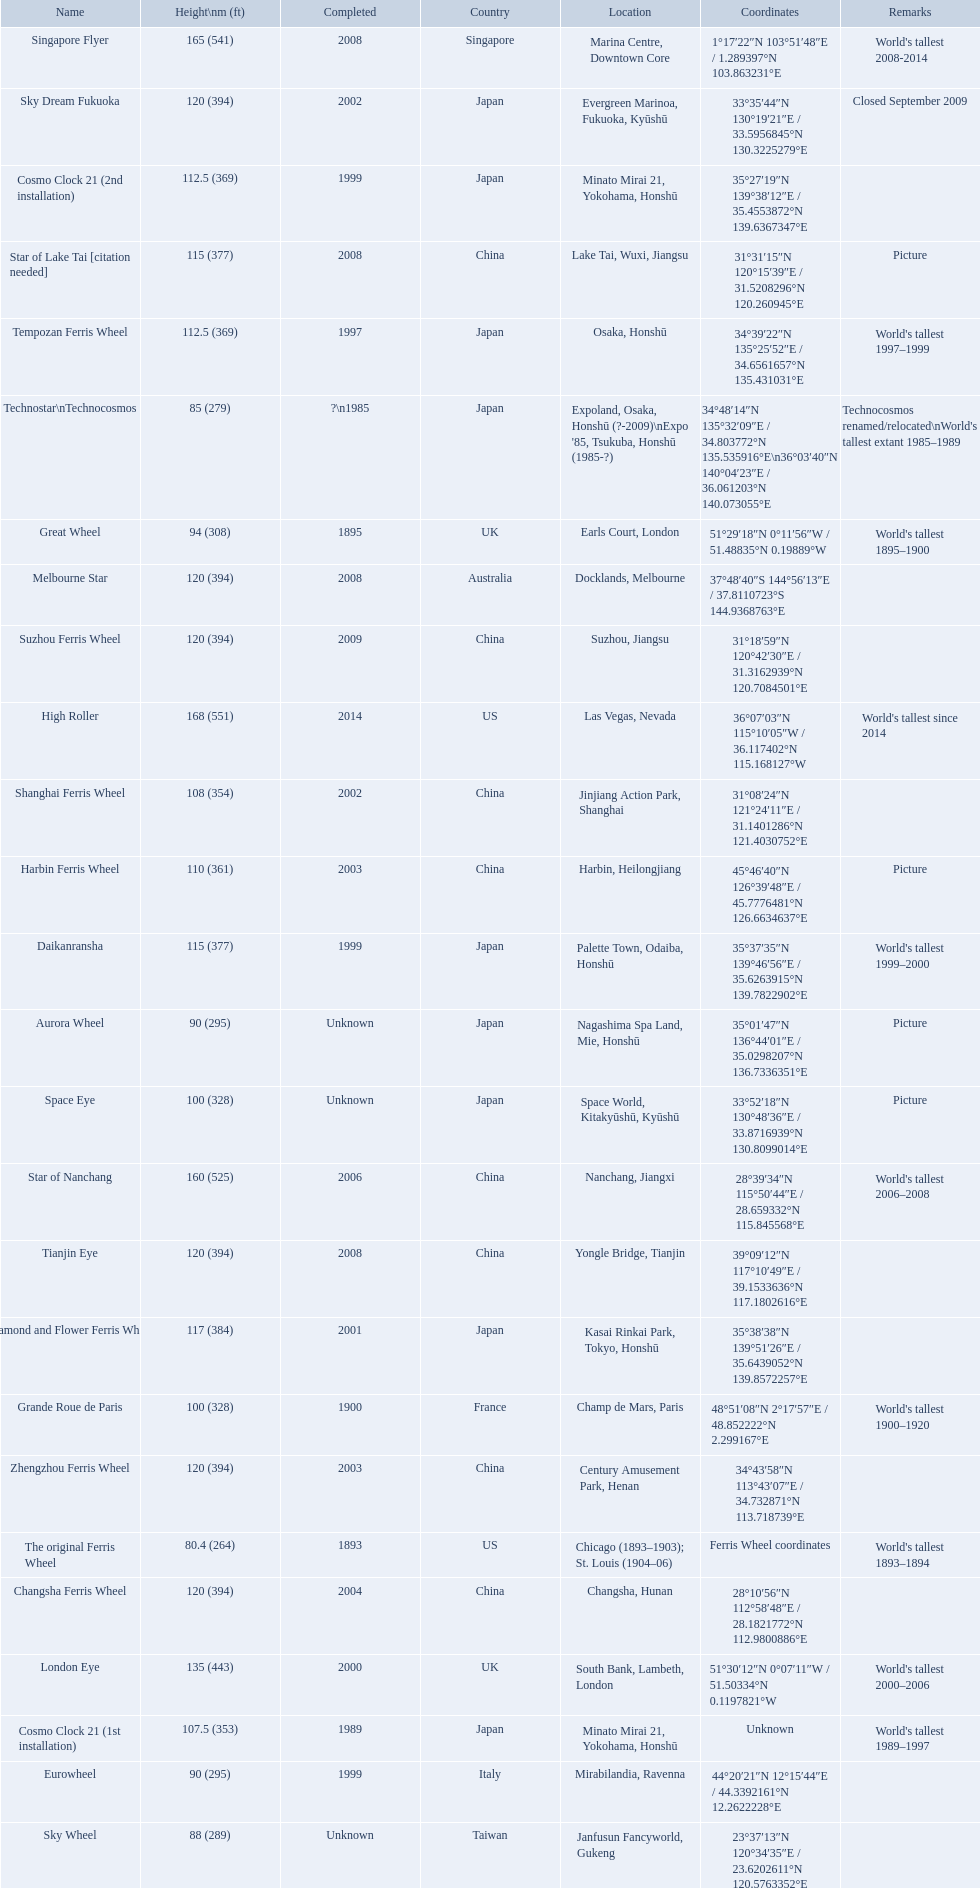What ferris wheels were completed in 2008 Singapore Flyer, Melbourne Star, Tianjin Eye, Star of Lake Tai [citation needed]. Would you be able to parse every entry in this table? {'header': ['Name', 'Height\\nm (ft)', 'Completed', 'Country', 'Location', 'Coordinates', 'Remarks'], 'rows': [['Singapore Flyer', '165 (541)', '2008', 'Singapore', 'Marina Centre, Downtown Core', '1°17′22″N 103°51′48″E\ufeff / \ufeff1.289397°N 103.863231°E', "World's tallest 2008-2014"], ['Sky Dream Fukuoka', '120 (394)', '2002', 'Japan', 'Evergreen Marinoa, Fukuoka, Kyūshū', '33°35′44″N 130°19′21″E\ufeff / \ufeff33.5956845°N 130.3225279°E', 'Closed September 2009'], ['Cosmo Clock 21 (2nd installation)', '112.5 (369)', '1999', 'Japan', 'Minato Mirai 21, Yokohama, Honshū', '35°27′19″N 139°38′12″E\ufeff / \ufeff35.4553872°N 139.6367347°E', ''], ['Star of Lake Tai\xa0[citation needed]', '115 (377)', '2008', 'China', 'Lake Tai, Wuxi, Jiangsu', '31°31′15″N 120°15′39″E\ufeff / \ufeff31.5208296°N 120.260945°E', 'Picture'], ['Tempozan Ferris Wheel', '112.5 (369)', '1997', 'Japan', 'Osaka, Honshū', '34°39′22″N 135°25′52″E\ufeff / \ufeff34.6561657°N 135.431031°E', "World's tallest 1997–1999"], ['Technostar\\nTechnocosmos', '85 (279)', '?\\n1985', 'Japan', "Expoland, Osaka, Honshū (?-2009)\\nExpo '85, Tsukuba, Honshū (1985-?)", '34°48′14″N 135°32′09″E\ufeff / \ufeff34.803772°N 135.535916°E\\n36°03′40″N 140°04′23″E\ufeff / \ufeff36.061203°N 140.073055°E', "Technocosmos renamed/relocated\\nWorld's tallest extant 1985–1989"], ['Great Wheel', '94 (308)', '1895', 'UK', 'Earls Court, London', '51°29′18″N 0°11′56″W\ufeff / \ufeff51.48835°N 0.19889°W', "World's tallest 1895–1900"], ['Melbourne Star', '120 (394)', '2008', 'Australia', 'Docklands, Melbourne', '37°48′40″S 144°56′13″E\ufeff / \ufeff37.8110723°S 144.9368763°E', ''], ['Suzhou Ferris Wheel', '120 (394)', '2009', 'China', 'Suzhou, Jiangsu', '31°18′59″N 120°42′30″E\ufeff / \ufeff31.3162939°N 120.7084501°E', ''], ['High Roller', '168 (551)', '2014', 'US', 'Las Vegas, Nevada', '36°07′03″N 115°10′05″W\ufeff / \ufeff36.117402°N 115.168127°W', "World's tallest since 2014"], ['Shanghai Ferris Wheel', '108 (354)', '2002', 'China', 'Jinjiang Action Park, Shanghai', '31°08′24″N 121°24′11″E\ufeff / \ufeff31.1401286°N 121.4030752°E', ''], ['Harbin Ferris Wheel', '110 (361)', '2003', 'China', 'Harbin, Heilongjiang', '45°46′40″N 126°39′48″E\ufeff / \ufeff45.7776481°N 126.6634637°E', 'Picture'], ['Daikanransha', '115 (377)', '1999', 'Japan', 'Palette Town, Odaiba, Honshū', '35°37′35″N 139°46′56″E\ufeff / \ufeff35.6263915°N 139.7822902°E', "World's tallest 1999–2000"], ['Aurora Wheel', '90 (295)', 'Unknown', 'Japan', 'Nagashima Spa Land, Mie, Honshū', '35°01′47″N 136°44′01″E\ufeff / \ufeff35.0298207°N 136.7336351°E', 'Picture'], ['Space Eye', '100 (328)', 'Unknown', 'Japan', 'Space World, Kitakyūshū, Kyūshū', '33°52′18″N 130°48′36″E\ufeff / \ufeff33.8716939°N 130.8099014°E', 'Picture'], ['Star of Nanchang', '160 (525)', '2006', 'China', 'Nanchang, Jiangxi', '28°39′34″N 115°50′44″E\ufeff / \ufeff28.659332°N 115.845568°E', "World's tallest 2006–2008"], ['Tianjin Eye', '120 (394)', '2008', 'China', 'Yongle Bridge, Tianjin', '39°09′12″N 117°10′49″E\ufeff / \ufeff39.1533636°N 117.1802616°E', ''], ['Diamond\xa0and\xa0Flower\xa0Ferris\xa0Wheel', '117 (384)', '2001', 'Japan', 'Kasai Rinkai Park, Tokyo, Honshū', '35°38′38″N 139°51′26″E\ufeff / \ufeff35.6439052°N 139.8572257°E', ''], ['Grande Roue de Paris', '100 (328)', '1900', 'France', 'Champ de Mars, Paris', '48°51′08″N 2°17′57″E\ufeff / \ufeff48.852222°N 2.299167°E', "World's tallest 1900–1920"], ['Zhengzhou Ferris Wheel', '120 (394)', '2003', 'China', 'Century Amusement Park, Henan', '34°43′58″N 113°43′07″E\ufeff / \ufeff34.732871°N 113.718739°E', ''], ['The original Ferris Wheel', '80.4 (264)', '1893', 'US', 'Chicago (1893–1903); St. Louis (1904–06)', 'Ferris Wheel coordinates', "World's tallest 1893–1894"], ['Changsha Ferris Wheel', '120 (394)', '2004', 'China', 'Changsha, Hunan', '28°10′56″N 112°58′48″E\ufeff / \ufeff28.1821772°N 112.9800886°E', ''], ['London Eye', '135 (443)', '2000', 'UK', 'South Bank, Lambeth, London', '51°30′12″N 0°07′11″W\ufeff / \ufeff51.50334°N 0.1197821°W', "World's tallest 2000–2006"], ['Cosmo Clock 21 (1st installation)', '107.5 (353)', '1989', 'Japan', 'Minato Mirai 21, Yokohama, Honshū', 'Unknown', "World's tallest 1989–1997"], ['Eurowheel', '90 (295)', '1999', 'Italy', 'Mirabilandia, Ravenna', '44°20′21″N 12°15′44″E\ufeff / \ufeff44.3392161°N 12.2622228°E', ''], ['Sky Wheel', '88 (289)', 'Unknown', 'Taiwan', 'Janfusun Fancyworld, Gukeng', '23°37′13″N 120°34′35″E\ufeff / \ufeff23.6202611°N 120.5763352°E', '']]} Of these, which has the height of 165? Singapore Flyer. What are all of the ferris wheel names? High Roller, Singapore Flyer, Star of Nanchang, London Eye, Suzhou Ferris Wheel, Melbourne Star, Tianjin Eye, Changsha Ferris Wheel, Zhengzhou Ferris Wheel, Sky Dream Fukuoka, Diamond and Flower Ferris Wheel, Star of Lake Tai [citation needed], Daikanransha, Cosmo Clock 21 (2nd installation), Tempozan Ferris Wheel, Harbin Ferris Wheel, Shanghai Ferris Wheel, Cosmo Clock 21 (1st installation), Space Eye, Grande Roue de Paris, Great Wheel, Aurora Wheel, Eurowheel, Sky Wheel, Technostar\nTechnocosmos, The original Ferris Wheel. What was the height of each one? 168 (551), 165 (541), 160 (525), 135 (443), 120 (394), 120 (394), 120 (394), 120 (394), 120 (394), 120 (394), 117 (384), 115 (377), 115 (377), 112.5 (369), 112.5 (369), 110 (361), 108 (354), 107.5 (353), 100 (328), 100 (328), 94 (308), 90 (295), 90 (295), 88 (289), 85 (279), 80.4 (264). And when were they completed? 2014, 2008, 2006, 2000, 2009, 2008, 2008, 2004, 2003, 2002, 2001, 2008, 1999, 1999, 1997, 2003, 2002, 1989, Unknown, 1900, 1895, Unknown, 1999, Unknown, ?\n1985, 1893. Which were completed in 2008? Singapore Flyer, Melbourne Star, Tianjin Eye, Star of Lake Tai [citation needed]. And of those ferris wheels, which had a height of 165 meters? Singapore Flyer. 